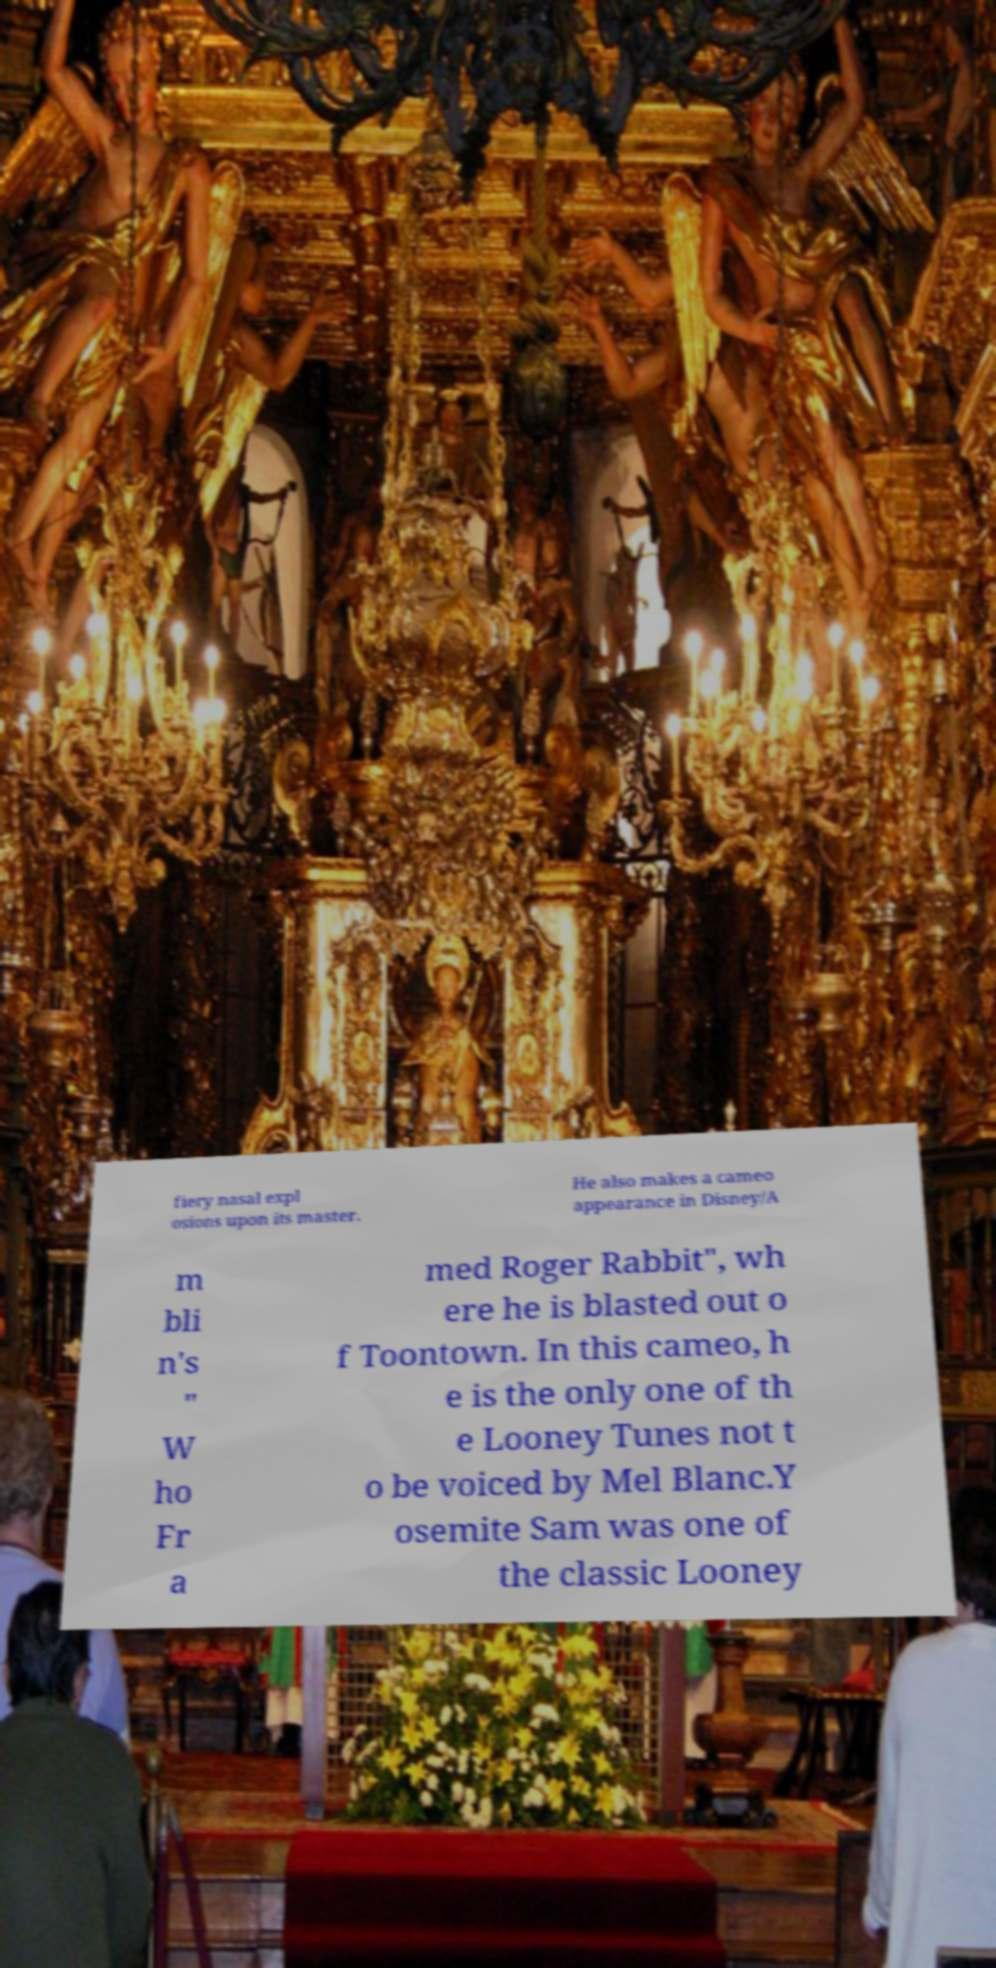Can you read and provide the text displayed in the image?This photo seems to have some interesting text. Can you extract and type it out for me? fiery nasal expl osions upon its master. He also makes a cameo appearance in Disney/A m bli n's " W ho Fr a med Roger Rabbit", wh ere he is blasted out o f Toontown. In this cameo, h e is the only one of th e Looney Tunes not t o be voiced by Mel Blanc.Y osemite Sam was one of the classic Looney 